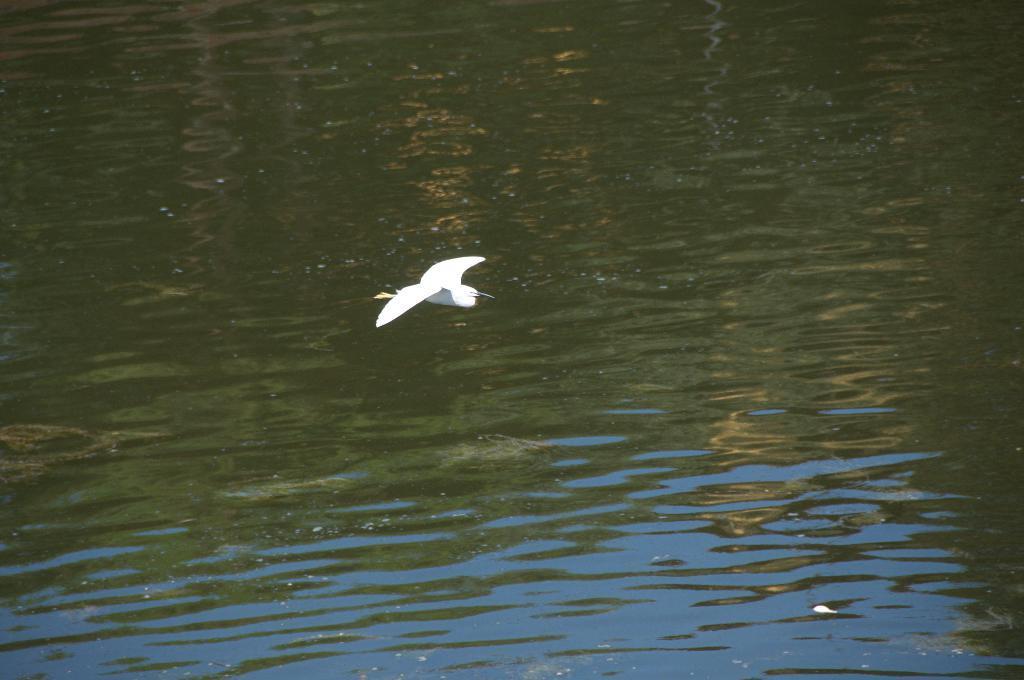Could you give a brief overview of what you see in this image? In the picture I can see a white color bird is flying in the air. In the background I can see the water. 